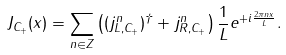Convert formula to latex. <formula><loc_0><loc_0><loc_500><loc_500>J _ { C _ { + } } ( x ) = \sum _ { n \in Z } \left ( ( j _ { L , C _ { + } } ^ { n } ) ^ { \dagger } + j _ { R , C _ { + } } ^ { n } \right ) \frac { 1 } { L } e ^ { + i \frac { 2 \pi n x } { L } } .</formula> 